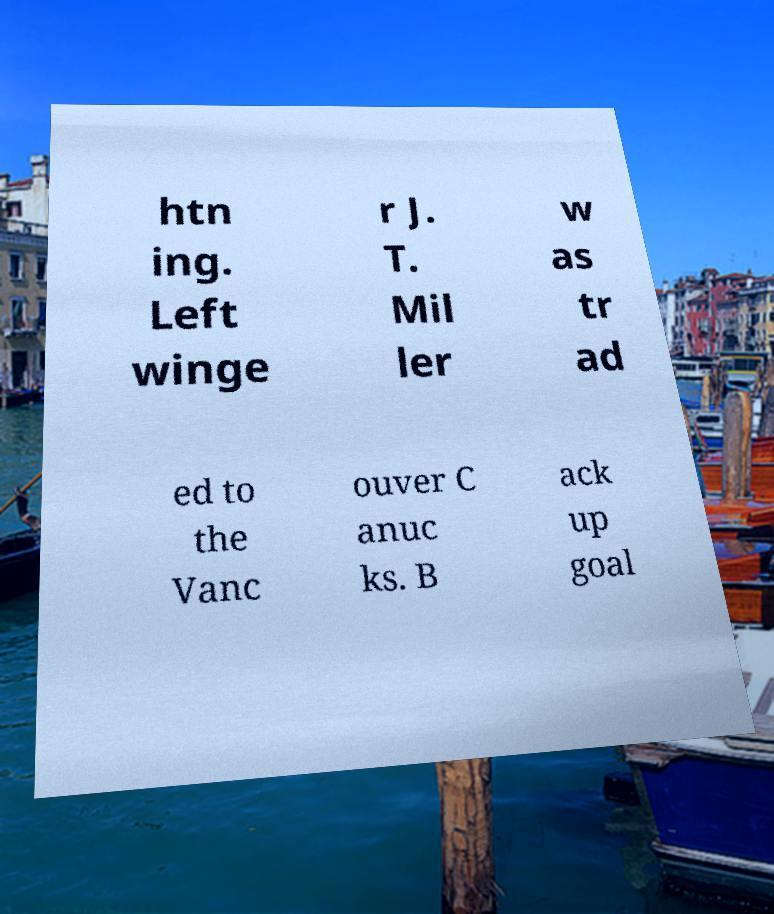Please identify and transcribe the text found in this image. htn ing. Left winge r J. T. Mil ler w as tr ad ed to the Vanc ouver C anuc ks. B ack up goal 